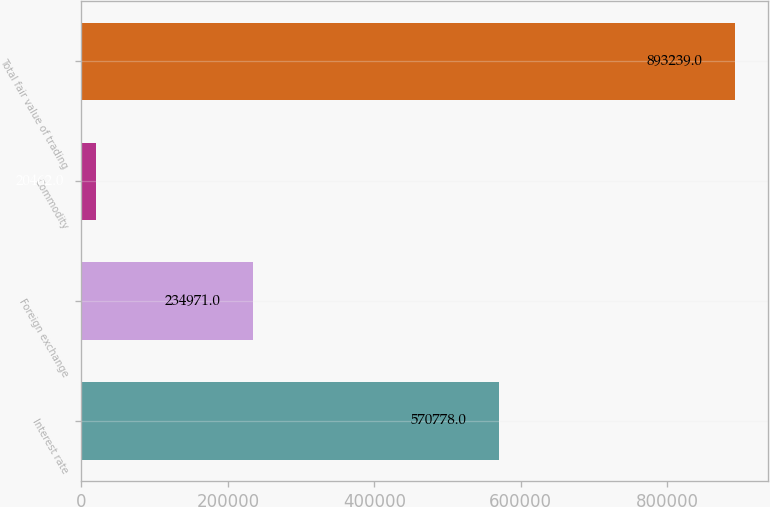Convert chart. <chart><loc_0><loc_0><loc_500><loc_500><bar_chart><fcel>Interest rate<fcel>Foreign exchange<fcel>Commodity<fcel>Total fair value of trading<nl><fcel>570778<fcel>234971<fcel>20462<fcel>893239<nl></chart> 